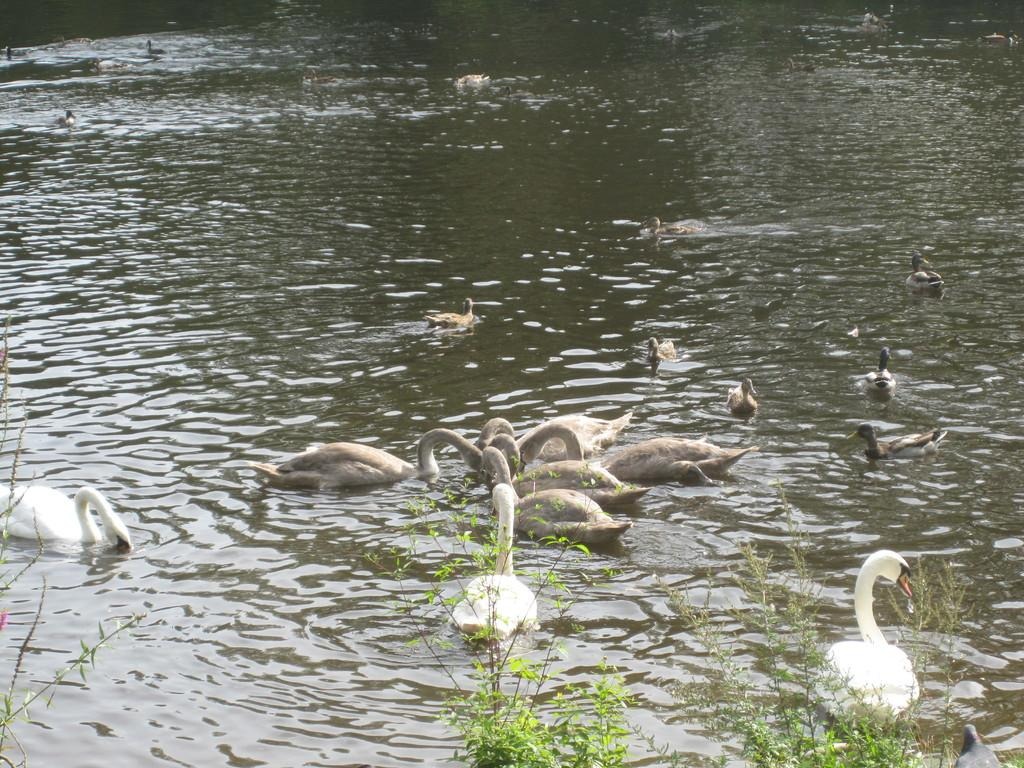What type of animals can be seen in the image? There are swans and ducks in the image. Where are the swans and ducks located? The swans and ducks are in the water. What else can be seen in the image besides the animals? There are plants visible at the bottom of the image. Can you tell me how many nests are visible in the image? There are no nests visible in the image; it features swans and ducks in the water with plants at the bottom. What type of dirt can be seen in the image? There is no dirt present in the image; it features swans and ducks in the water with plants at the bottom. 